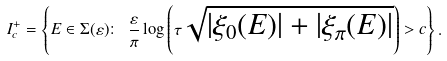Convert formula to latex. <formula><loc_0><loc_0><loc_500><loc_500>I ^ { + } _ { c } = \left \{ E \in \Sigma ( \varepsilon ) \colon \ \frac { \varepsilon } { \pi } \log \left ( \tau \sqrt { | \xi _ { 0 } ( E ) | + | \xi _ { \pi } ( E ) | } \right ) > c \right \} .</formula> 